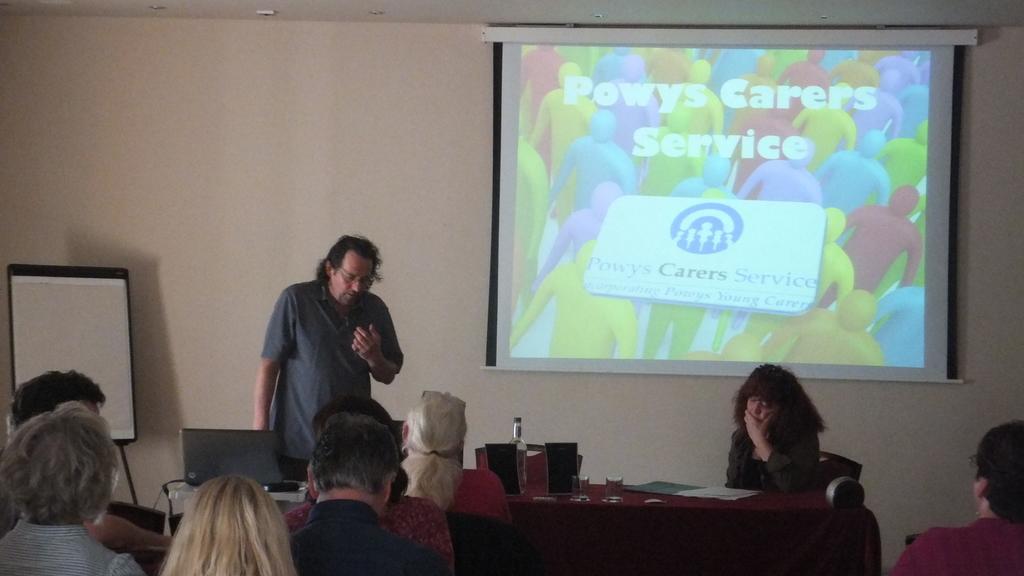Could you give a brief overview of what you see in this image? In the center we can see one man standing. In the bottom they were few persons were sitting on the chair. And there is a table on table we can see water bottle,glass,paper etc. In the background there is a screen,wall and board. 